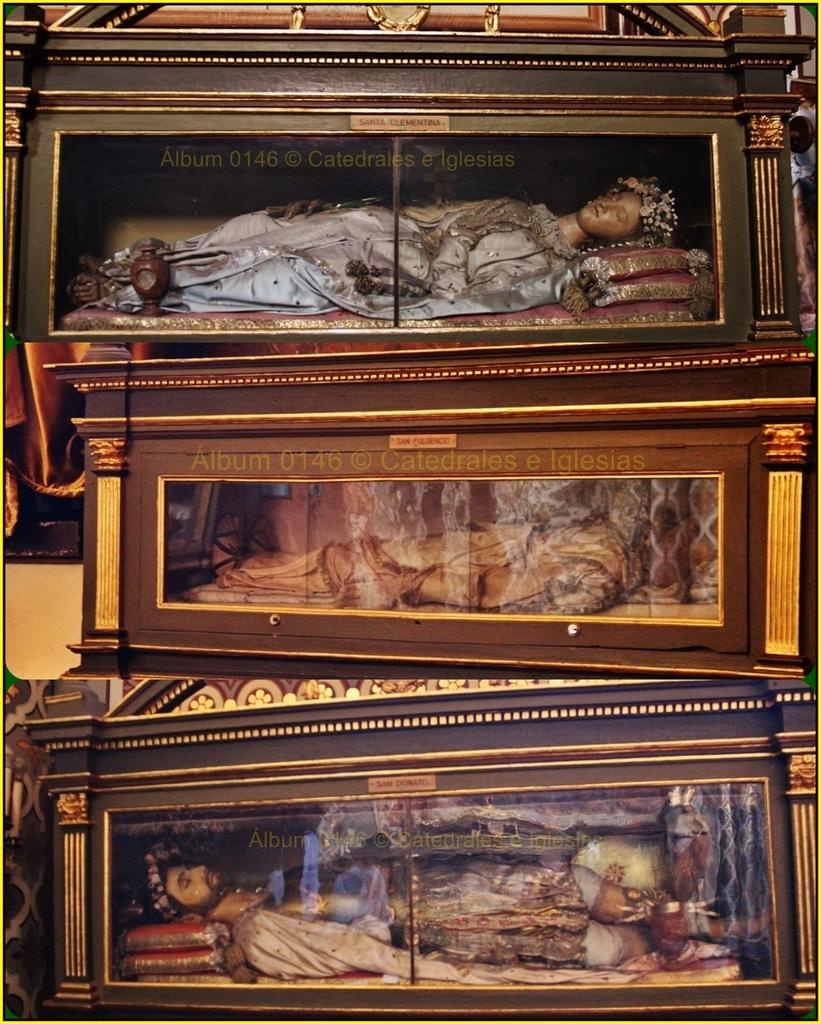Could you give a brief overview of what you see in this image? In this image I can see few wooden boxes which are brown in color and I can see the glass surface of the box through which I can see few statues which are in the shape of a person in the wooden boxes. 